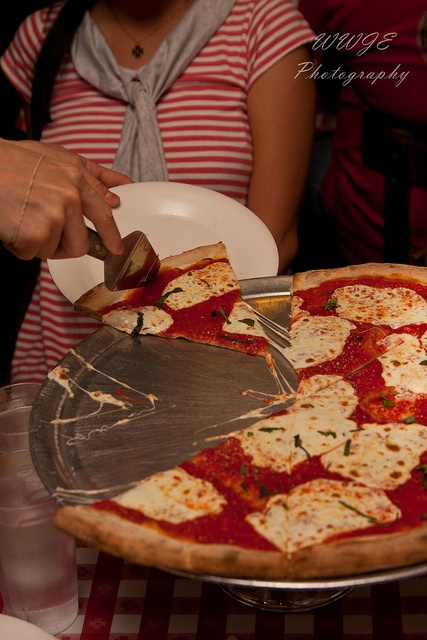Describe the objects in this image and their specific colors. I can see people in black, maroon, and brown tones, pizza in black, tan, maroon, and brown tones, dining table in black, maroon, and gray tones, cup in black, maroon, brown, and gray tones, and pizza in black, maroon, brown, and tan tones in this image. 